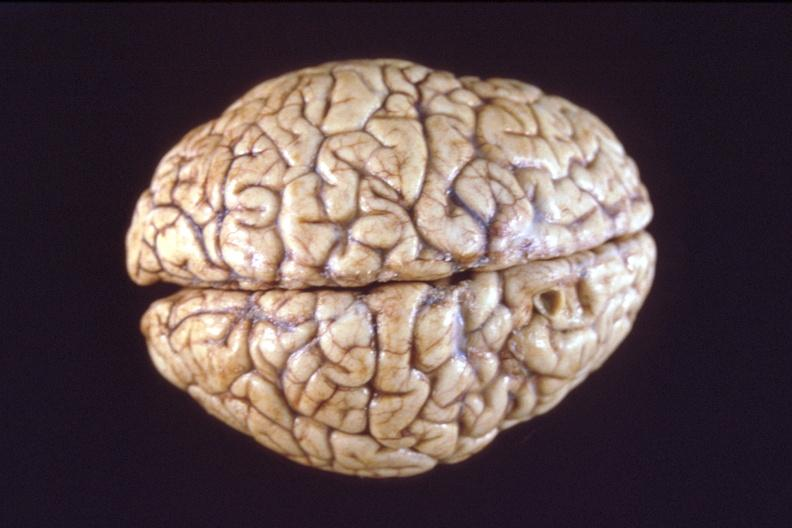does this image show brain, breast cancer metastasis to meninges?
Answer the question using a single word or phrase. Yes 